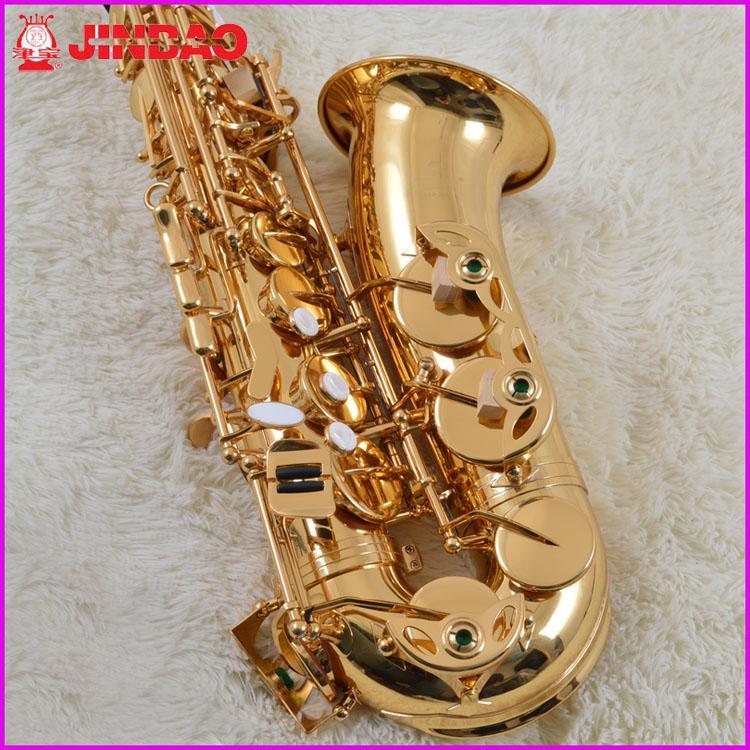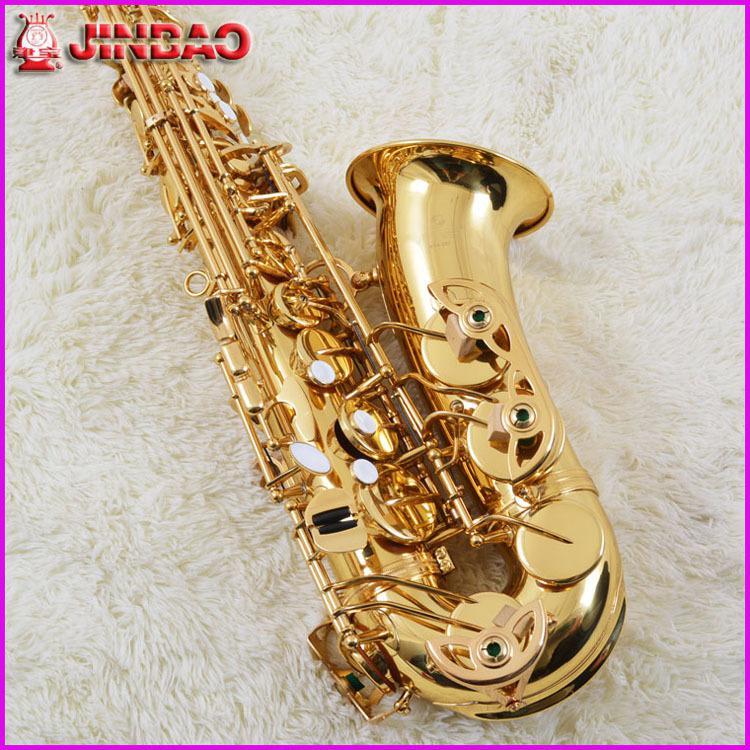The first image is the image on the left, the second image is the image on the right. For the images shown, is this caption "One of the images shows a saxophone and a pamphlet while the other shows only a saxophone." true? Answer yes or no. No. The first image is the image on the left, the second image is the image on the right. Considering the images on both sides, is "A tag is connected to the sax in the image on the right." valid? Answer yes or no. No. 